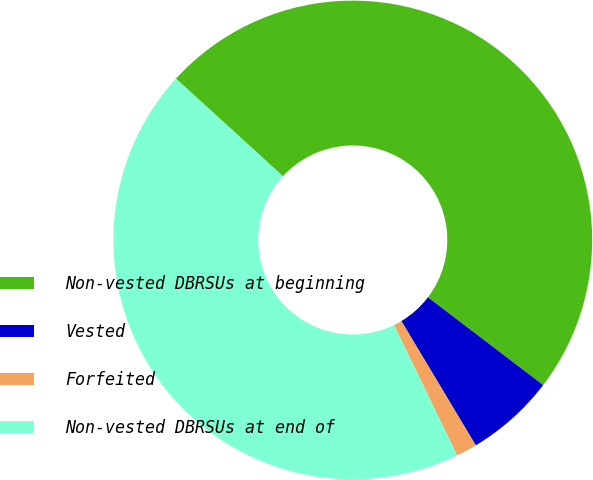Convert chart. <chart><loc_0><loc_0><loc_500><loc_500><pie_chart><fcel>Non-vested DBRSUs at beginning<fcel>Vested<fcel>Forfeited<fcel>Non-vested DBRSUs at end of<nl><fcel>48.59%<fcel>6.05%<fcel>1.41%<fcel>43.95%<nl></chart> 